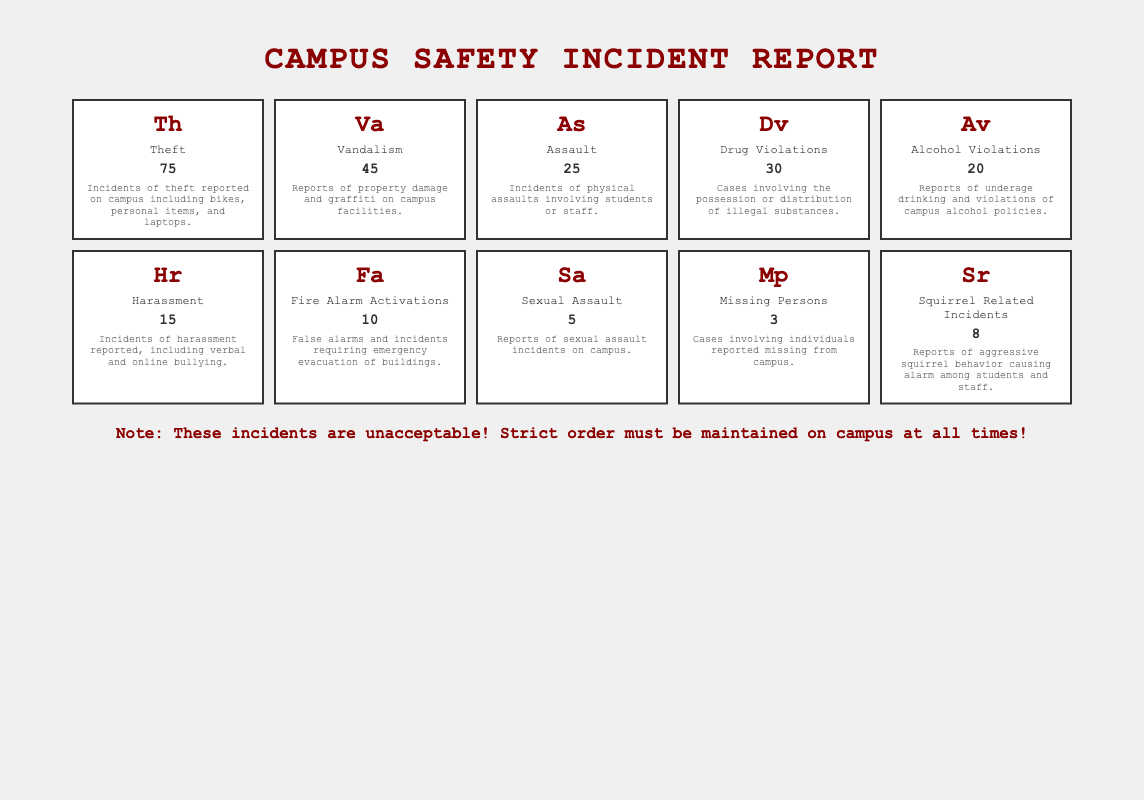What is the frequency of theft incidents on campus? The table indicates that theft incidents have a frequency of 75. I can find this information directly in the row corresponding to "Theft."
Answer: 75 How many total incidents are reported for alcohol and drug violations combined? I need to add the frequencies for Alcohol Violations (20) and Drug Violations (30). The sum is 20 + 30 = 50, indicating the combined frequency of these two types of incidents.
Answer: 50 Is the frequency of sexual assault incidents greater than that of theft incidents? The frequency of sexual assault incidents is 5, while theft incidents have a frequency of 75. Since 5 is not greater than 75, the answer is no.
Answer: No What is the type of incident with the lowest frequency? Scanning through the frequencies in the table, I see that Missing Persons has the lowest frequency at 3. I can confirm this by comparing all the frequencies listed.
Answer: Missing Persons What is the average frequency of all the incidents reported on campus? To find the average, I first sum all the frequencies: 75 + 45 + 25 + 30 + 20 + 15 + 10 + 5 + 3 + 8 = 336. There are 10 incident types in total, so I divide 336 by 10, which results in an average frequency of 33.6.
Answer: 33.6 How many more incidents of vandalism are reported compared to assault? The table shows that vandalism incidents total 45 and assault incidents total 25. To find the difference, I subtract: 45 - 25 = 20, indicating vandalism incidents exceed assaults by 20.
Answer: 20 Are there more incidents reported for squirrels than for sexual assault? The table shows squirrel-related incidents are 8 and sexual assault incidents are 5. Since 8 is greater than 5, the answer is yes.
Answer: Yes What percentage of the total incidents does harassment represent? First, I add all the frequencies (336) as before and then find the harassment frequency (15). The percentage can be calculated as (15/336) * 100, which is approximately 4.46%.
Answer: 4.46% 